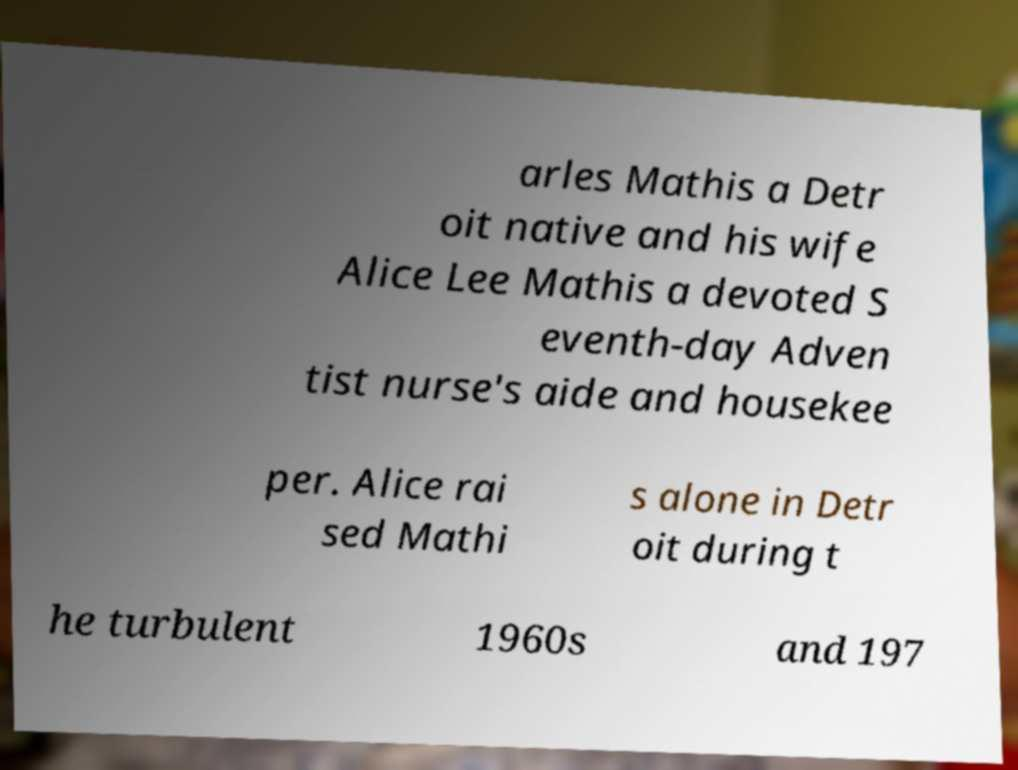I need the written content from this picture converted into text. Can you do that? arles Mathis a Detr oit native and his wife Alice Lee Mathis a devoted S eventh-day Adven tist nurse's aide and housekee per. Alice rai sed Mathi s alone in Detr oit during t he turbulent 1960s and 197 